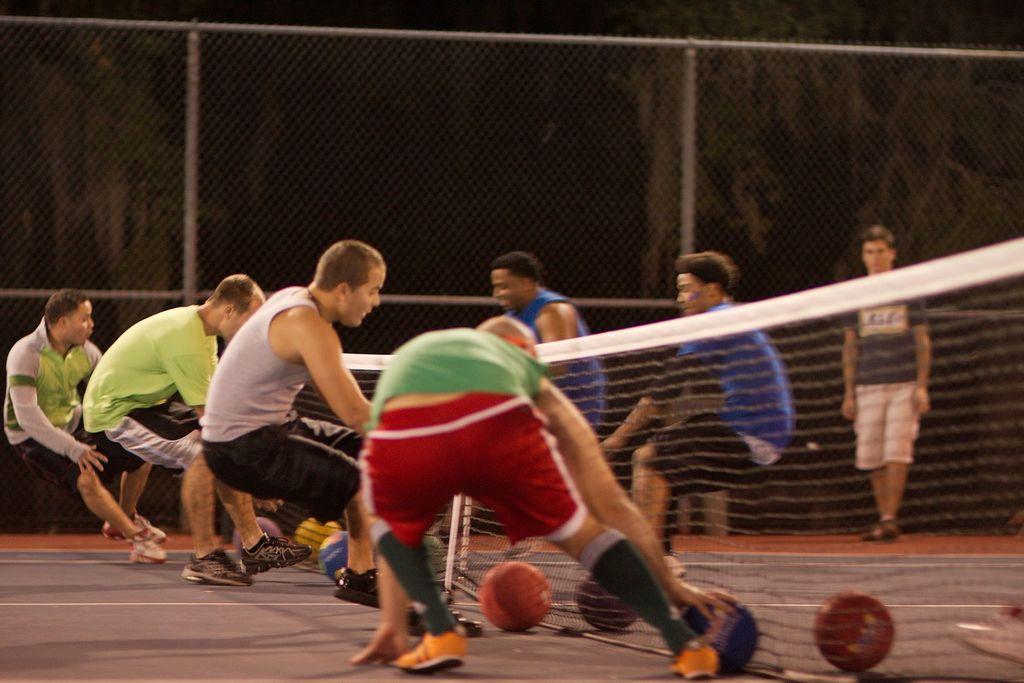Can you describe this image briefly? In the middle of the image a few men are playing with a few balls. There is a net. In the background there is a mesh and a man is walking on the floor. At the bottom of the image there is a floor. 